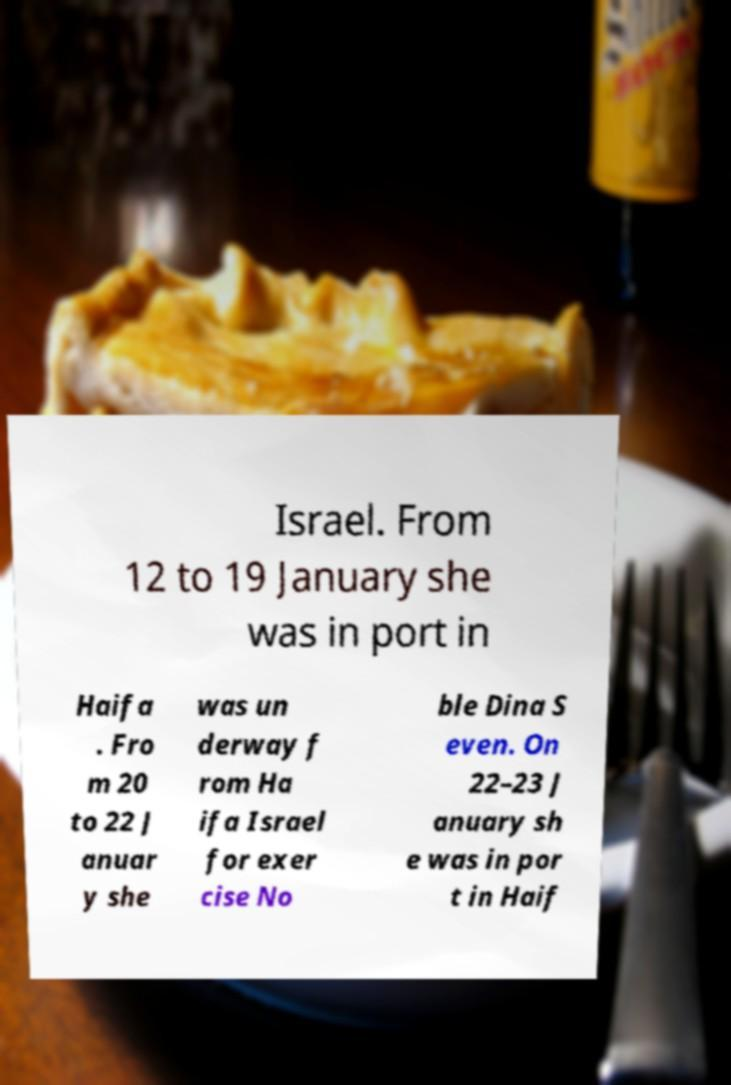Can you read and provide the text displayed in the image?This photo seems to have some interesting text. Can you extract and type it out for me? Israel. From 12 to 19 January she was in port in Haifa . Fro m 20 to 22 J anuar y she was un derway f rom Ha ifa Israel for exer cise No ble Dina S even. On 22–23 J anuary sh e was in por t in Haif 